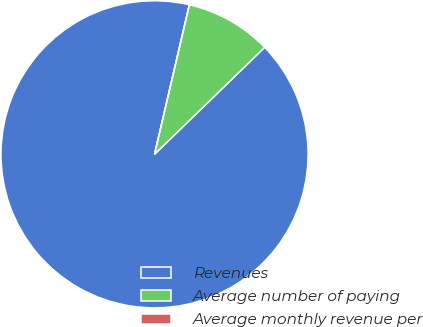Convert chart. <chart><loc_0><loc_0><loc_500><loc_500><pie_chart><fcel>Revenues<fcel>Average number of paying<fcel>Average monthly revenue per<nl><fcel>90.9%<fcel>9.09%<fcel>0.0%<nl></chart> 